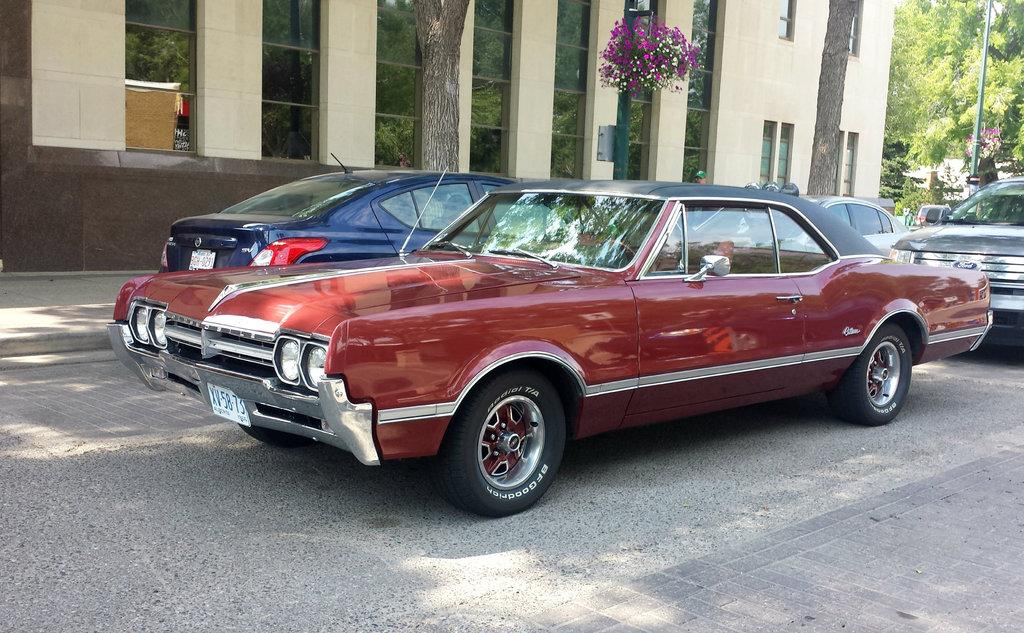What can be seen on the road in the image? There are many cars on the road in the image. What is visible in the background of the image? There is a building in the background of the image. What is visible in the top right corner of the image? The sky, a green color pole, a tree, and plants are visible in the top right corner of the image. Is there an oven visible in the image? No, there is no oven present in the image. Can you see any signs of hate in the image? No, there is no indication of hate in the image. 